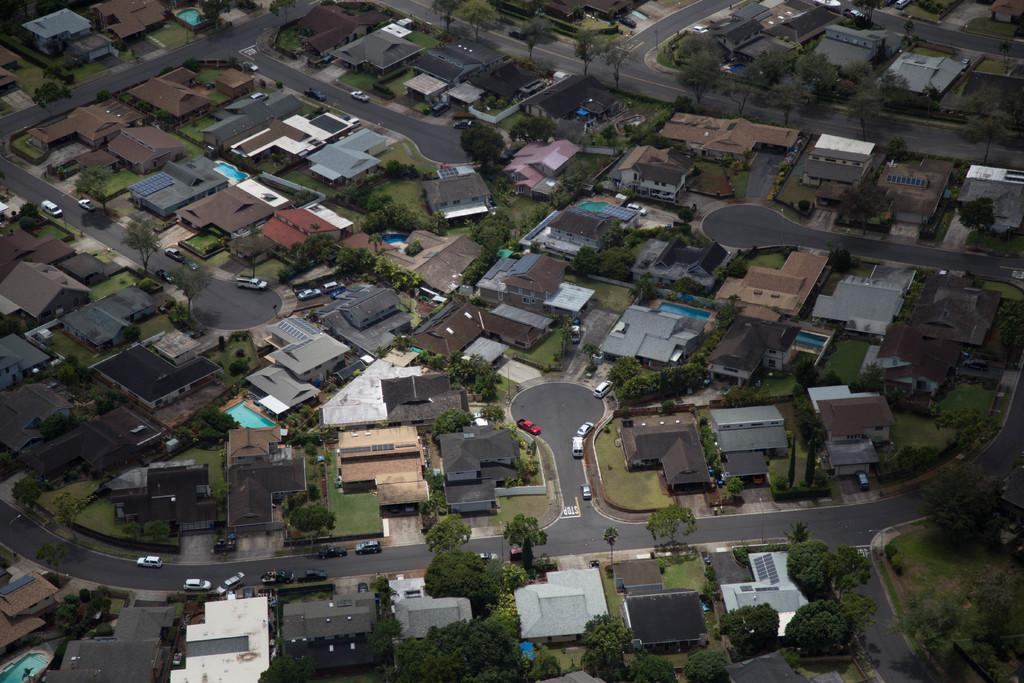What type of structures can be seen in the image? There are many buildings in the image. What other elements can be found in the image besides buildings? There are trees, roads, and vehicles in the image. What is the name of the person standing next to the tree in the image? There is no person standing next to the tree in the image. Can you tell me how many buttons are on the vehicles in the image? There are no buttons visible on the vehicles in the image. 